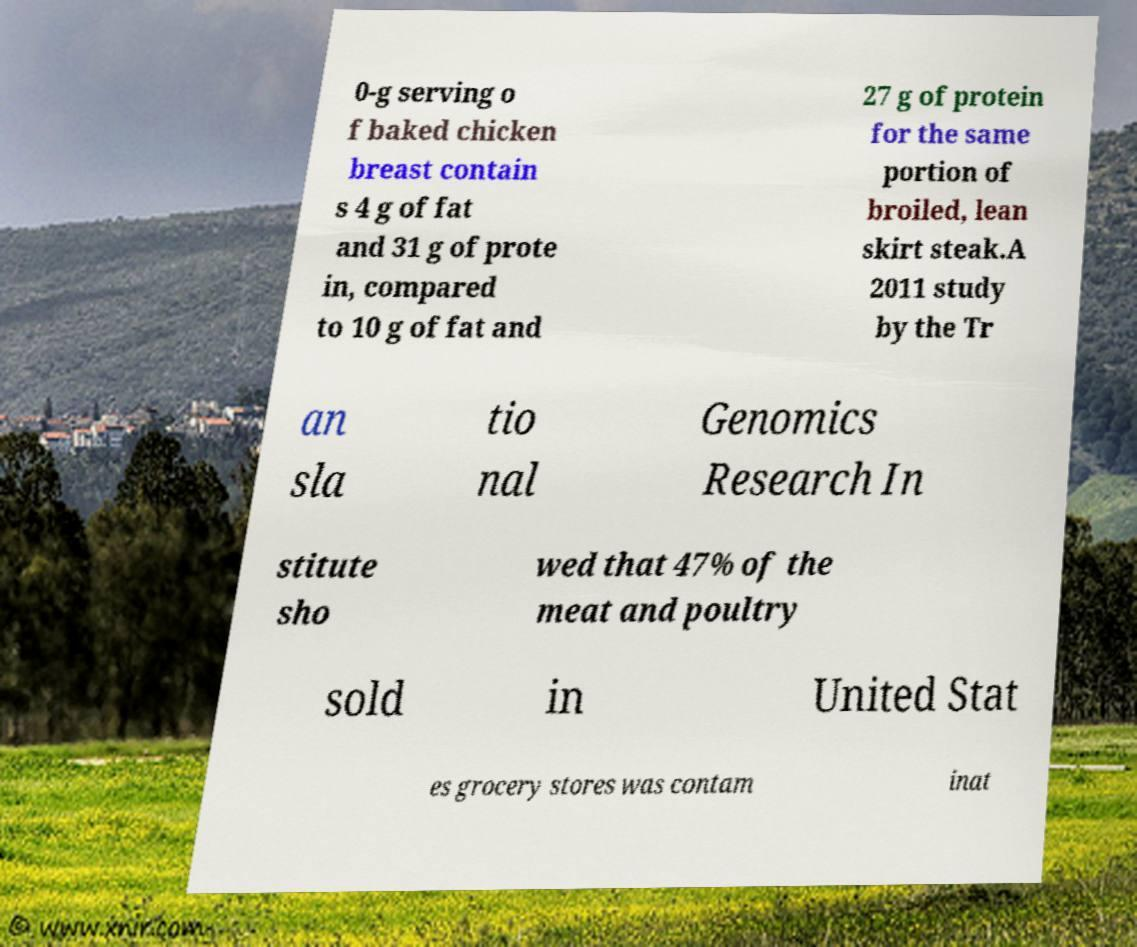What messages or text are displayed in this image? I need them in a readable, typed format. 0-g serving o f baked chicken breast contain s 4 g of fat and 31 g of prote in, compared to 10 g of fat and 27 g of protein for the same portion of broiled, lean skirt steak.A 2011 study by the Tr an sla tio nal Genomics Research In stitute sho wed that 47% of the meat and poultry sold in United Stat es grocery stores was contam inat 